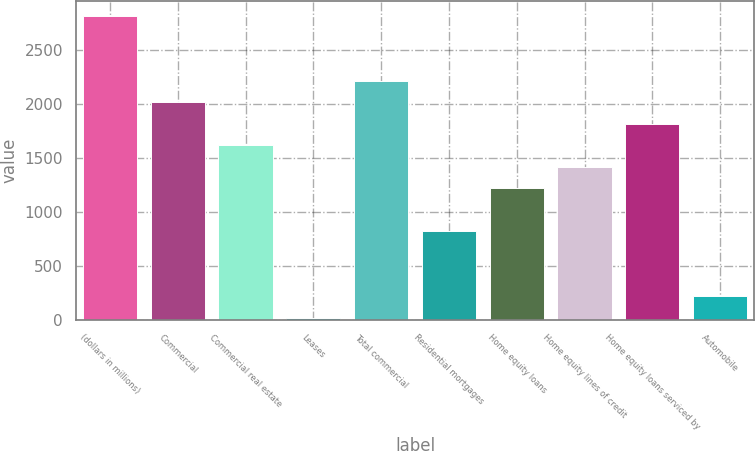Convert chart to OTSL. <chart><loc_0><loc_0><loc_500><loc_500><bar_chart><fcel>(dollars in millions)<fcel>Commercial<fcel>Commercial real estate<fcel>Leases<fcel>Total commercial<fcel>Residential mortgages<fcel>Home equity loans<fcel>Home equity lines of credit<fcel>Home equity loans serviced by<fcel>Automobile<nl><fcel>2809.2<fcel>2012<fcel>1613.4<fcel>19<fcel>2211.3<fcel>816.2<fcel>1214.8<fcel>1414.1<fcel>1812.7<fcel>218.3<nl></chart> 